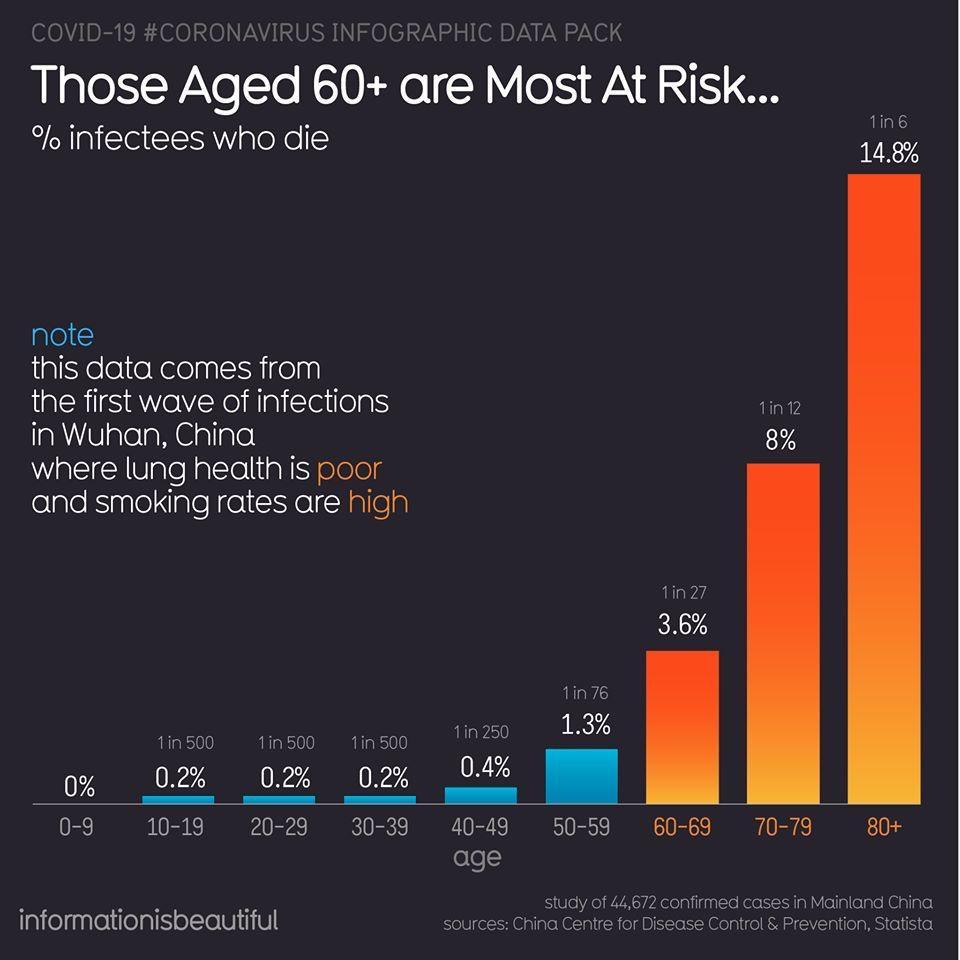Draw attention to some important aspects in this diagram. In the age group of 60-69, there is a ratio of 1 death in every 27 people who have been infected. According to the data, 1 in 12 people in the 70-79 age group are dying. According to recent data, approximately 1 in 6 people who have died from the COVID-19 pandemic are aged 80 and older. 